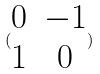Convert formula to latex. <formula><loc_0><loc_0><loc_500><loc_500>( \begin{matrix} 0 & - 1 \\ 1 & 0 \end{matrix} )</formula> 